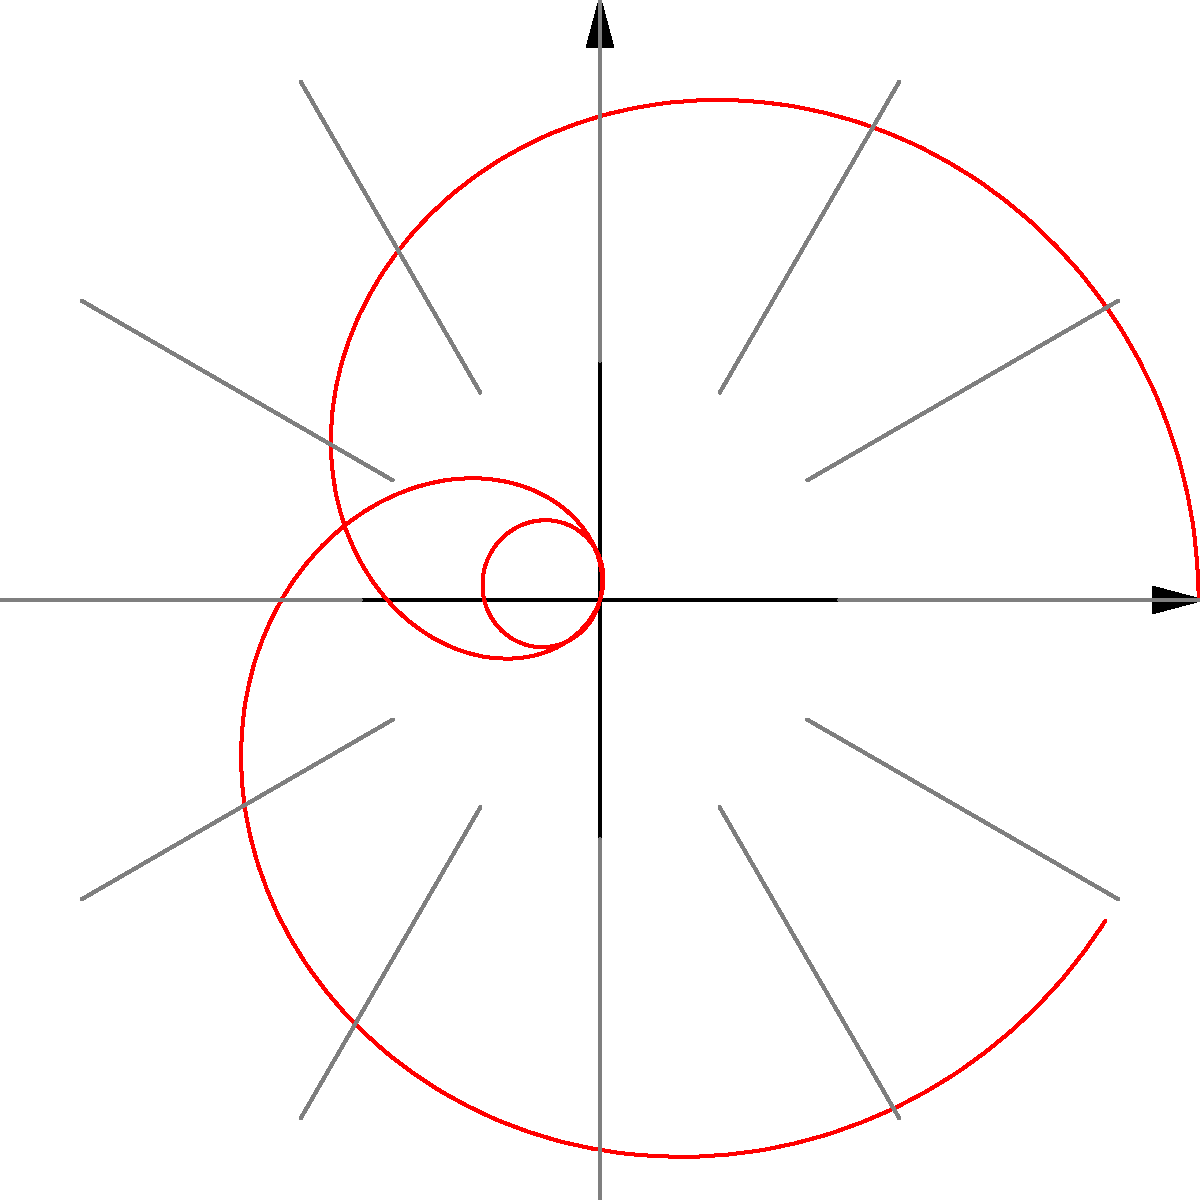The polar graph shows the growth rate of a high-risk investment over a 12-month period. The radial distance represents the growth rate percentage, and the angular position represents the month (with 0° being the start and moving counterclockwise). What is the maximum growth rate achieved during this period? To find the maximum growth rate, we need to analyze the graph and identify the point furthest from the origin. The steps are:

1. The graph is represented by the red curve, with blue dots marking each month.
2. The radial grid lines are spaced at intervals of 5 percentage points.
3. The outermost circle on the grid represents 25%.
4. Looking at the curve, we can see that it reaches its maximum at two points: around 90° (3 months) and 270° (9 months).
5. At these points, the curve extends slightly beyond the 25% circle.
6. The actual maximum can be calculated from the given function: $f(t) = 10 + 15\cos(\frac{2\pi t}{12})$
7. The maximum occurs when $\cos(\frac{2\pi t}{12}) = 1$, which happens at $t = 0, 6, 12$.
8. Plugging this into the function: $f(0) = f(6) = f(12) = 10 + 15 = 25$

Therefore, the maximum growth rate achieved is 25%.
Answer: 25% 